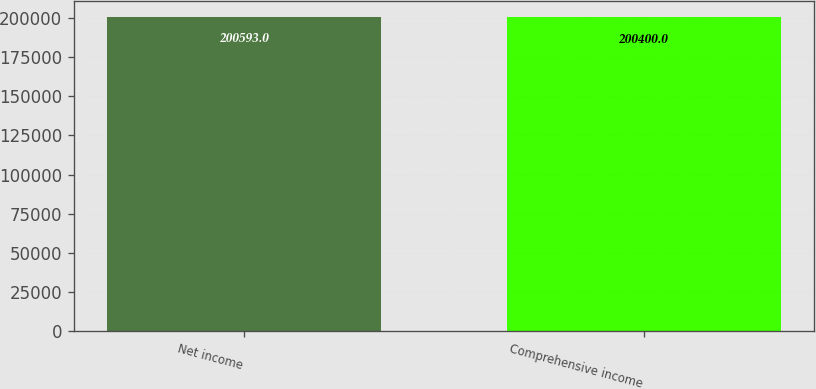<chart> <loc_0><loc_0><loc_500><loc_500><bar_chart><fcel>Net income<fcel>Comprehensive income<nl><fcel>200593<fcel>200400<nl></chart> 